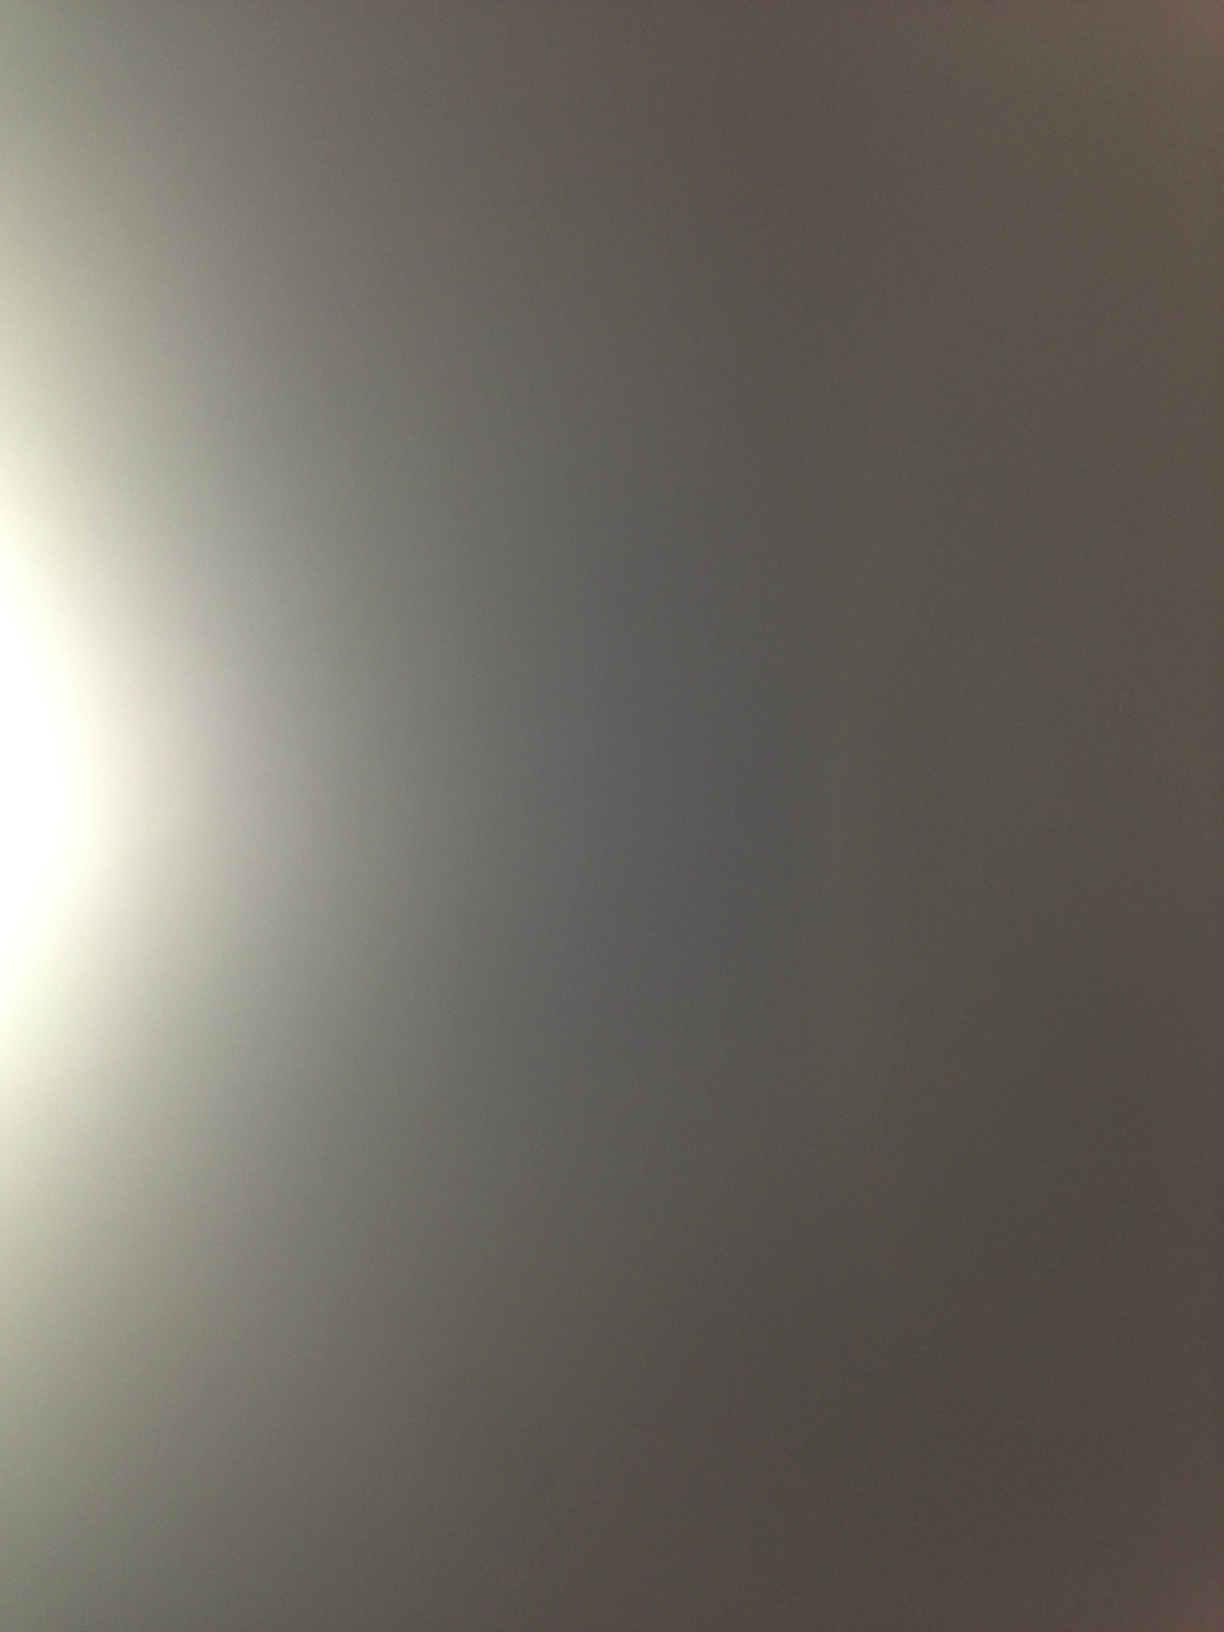Imagine this image is a background in a science fiction movie. What kind of scenes could take place here? In a science fiction movie, this gradient background could be the backdrop for a serene interstellar travel scene. It might depict the view from the window of a spaceship gliding through the tranquil depths of space, with distant stars and planets faintly visible at the edges. Alternatively, it could represent the surface of an uninhabited, desolate planet with a perpetually twilight sky, where explorers are setting foot on alien ground for the first time. Describe a detailed scene involving characters and actions. As the spaceship gracefully drifts through the silent cosmos, its sleek hull reflecting the soft gradient of light, Captain Mira stands at the viewport, her eyes fixed on the horizon. The crew behind her is abuzz with activity; engineers recalibrating instruments, scientists analyzing data from their latest planetary scan. Suddenly, a faint, glowing silhouette appears on the edge of the viewport, catching everyone's attention. It's an unknown celestial body, slowly emerging from the dark gradient background. An urgent alert beeps across the control room, signaling the anomaly. 'Prepare for reconnaissance,' Mira commands, and the crew swiftly moves to their stations. The gradient background, once calm and serene, now feels charged with anticipation as the spacecraft advances toward the mysterious entity, ready to uncover the secrets it holds. Let's be creative! Imagine this image depicts a secret portal. What kind of fantastical universe lies beyond it? Beyond this mystical portal lies a fantastical universe known as Lumarnia. In Lumarnia, the sky is a perpetual twilight, painted in shades of shimmering gold and silver, casting an enchanting glow over the landscape. Majestic floating islands, lush with bioluminescent flora and exotic fauna, drift gracefully through the air, interconnected by iridescent bridges of light. Rivers of liquid light cascade from these islands, creating ethereal waterfalls that defy gravity. The inhabitants, a harmonious blend of mythical creatures and advanced beings, coexist peacefully, guided by the ancient wisdom of the Celestial Library, a grand, floating structure where knowledge gleams in crystalline form. In this universe, magic and technology are intertwined, creating wonders beyond imagination: floating gardens, sentient constructs, and portals that lead to unexplored realms. The portal you've discovered is your entryway to adventure, unlocking the secrets and wonders of Lumarnia. 
In this image, I feel serene. Can you create a short scenario that correlates with this feeling? The image's soft hues and fading edges evoke a sense of calm and tranquility, mirroring the sensation of floating gently on a quiet lake at dusk. The water is motionless, reflecting the mellow gradient of the sky. As you lie back in your small wooden boat, the gentle lapping of the water against its sides is the only sound breaking the profound silence. Birds return to their nests, and the world seems to slow down, inviting you to envelop yourself in the serene embrace of nature's twilight. 
What realistic scenario could this image represent? Realistically, this image could represent a photograph taken of an overcast sky from an airplane window. The gradient effect might be due to the interplay of natural light and the window pane during either early morning or late evening, casting a muted, almost ethereal grayish hue over the scene. It might also depict a foggy day where the visibility is low, and the ambient light is diffused, creating a serene, almost otherworldly atmosphere. Give a detailed and extensive explanation of a realistic scenario for this image. This image could realistically represent a photograph taken during a high-altitude flight, capturing a layer of the atmosphere where weather conditions play artistically with light. During the flight, as the aircraft transitions from layers below a heavy cloud cover to emerging above them, the window reveals a surreal view. Below, dense clouds create an uninterrupted canvas of white, while the sun, just on the horizon, casts a gradient of light through the thinner upper layers of the atmosphere. This results in a soft diffusion of light that transitions from bright near the horizon to darker as it recedes upward, blending into the endless sky. As passengers look out, they see this beautiful gradient, accompanied perhaps by the shadow of the airplane gliding silently across the cloud tops. This serene yet eerie visual signifies the boundary where the bustling life below meets the tranquil, isolated expanse above, embodying a literal and metaphorical ascent into peace and solitude. 